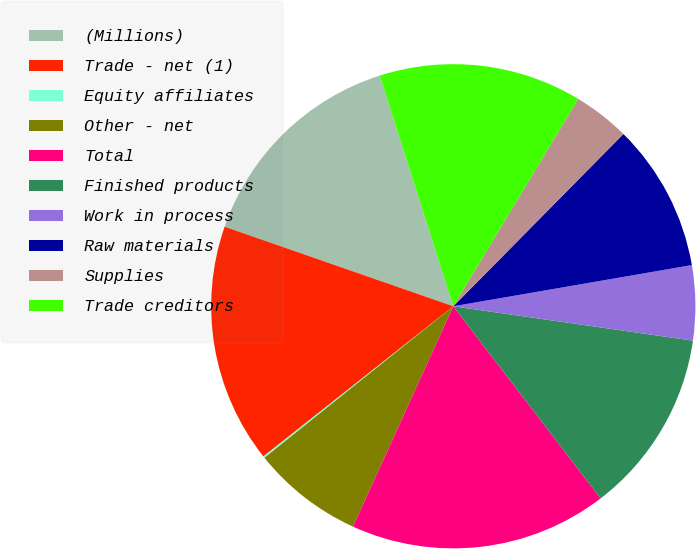Convert chart to OTSL. <chart><loc_0><loc_0><loc_500><loc_500><pie_chart><fcel>(Millions)<fcel>Trade - net (1)<fcel>Equity affiliates<fcel>Other - net<fcel>Total<fcel>Finished products<fcel>Work in process<fcel>Raw materials<fcel>Supplies<fcel>Trade creditors<nl><fcel>14.76%<fcel>15.98%<fcel>0.11%<fcel>7.44%<fcel>17.21%<fcel>12.32%<fcel>4.99%<fcel>9.88%<fcel>3.77%<fcel>13.54%<nl></chart> 